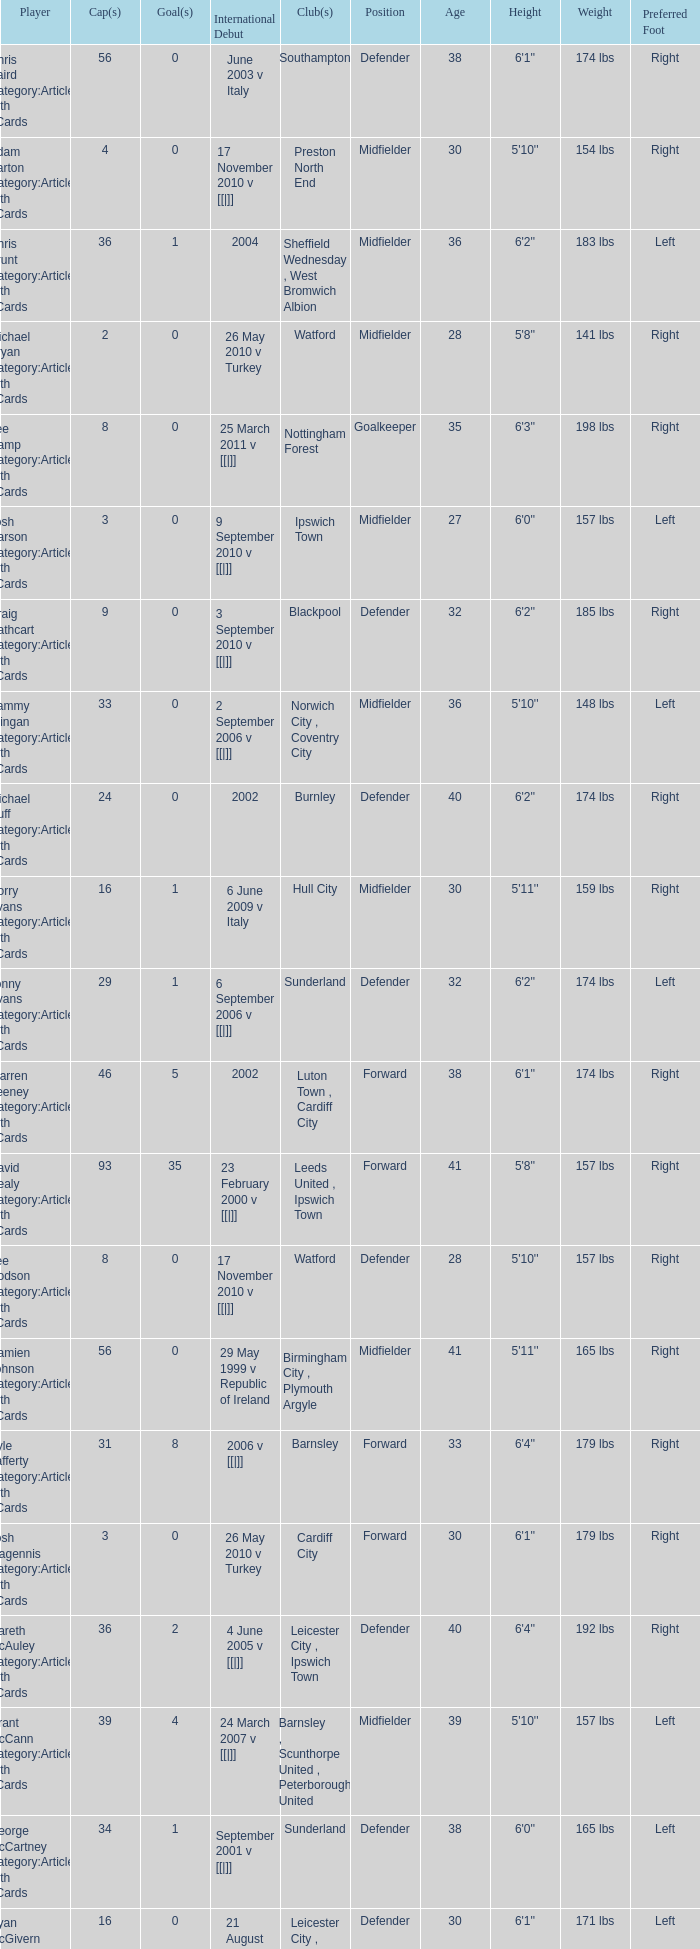How many caps figures for the Doncaster Rovers? 1.0. 